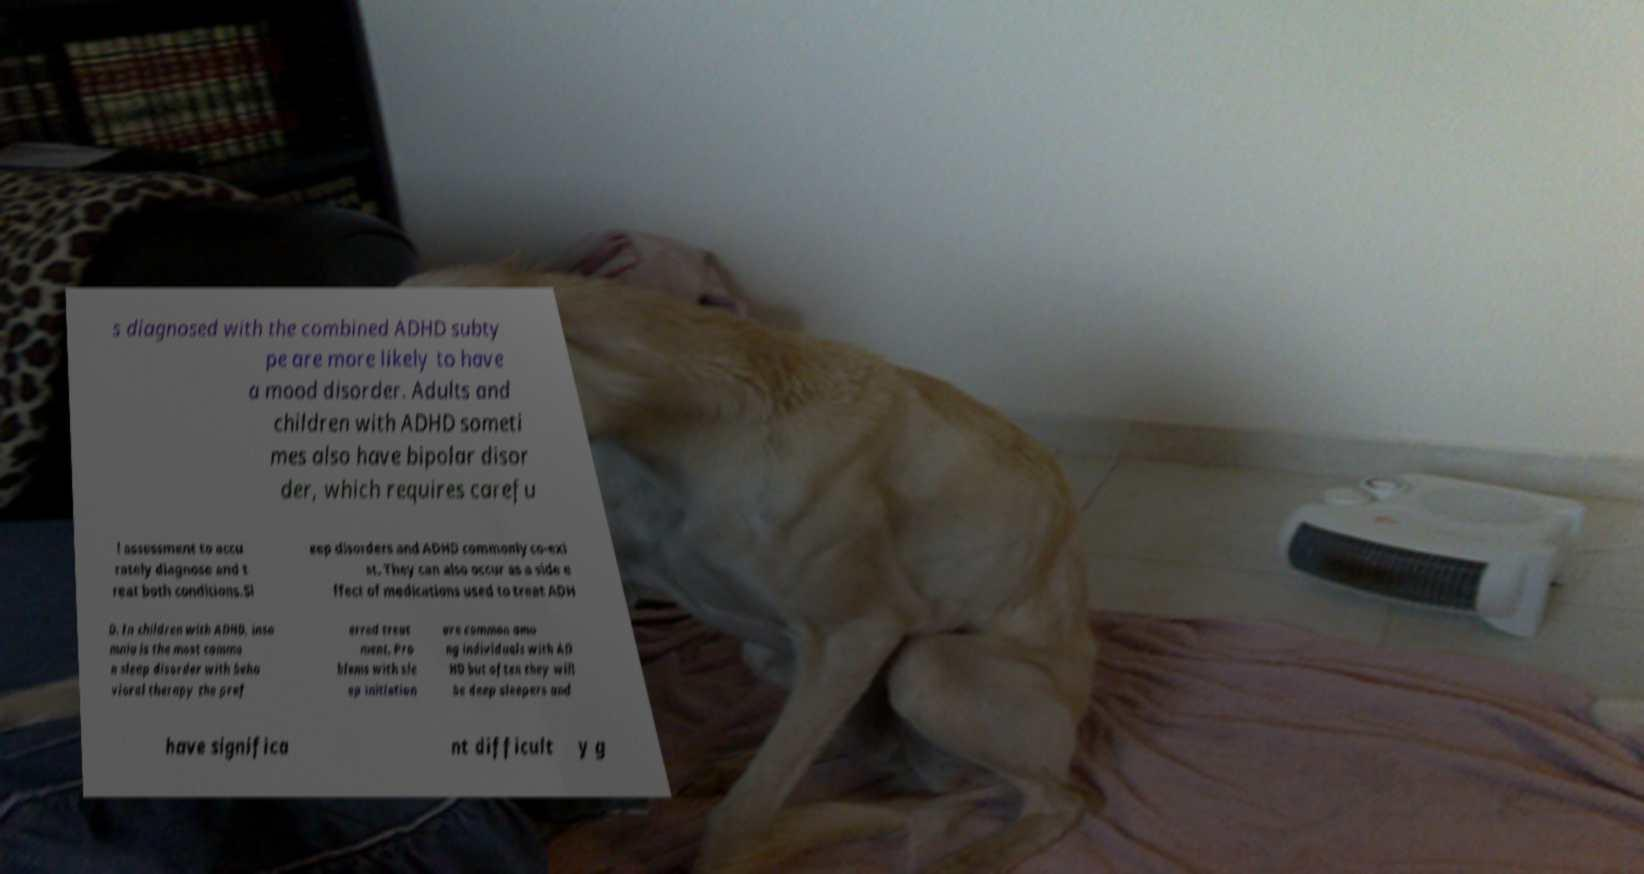I need the written content from this picture converted into text. Can you do that? s diagnosed with the combined ADHD subty pe are more likely to have a mood disorder. Adults and children with ADHD someti mes also have bipolar disor der, which requires carefu l assessment to accu rately diagnose and t reat both conditions.Sl eep disorders and ADHD commonly co-exi st. They can also occur as a side e ffect of medications used to treat ADH D. In children with ADHD, inso mnia is the most commo n sleep disorder with beha vioral therapy the pref erred treat ment. Pro blems with sle ep initiation are common amo ng individuals with AD HD but often they will be deep sleepers and have significa nt difficult y g 